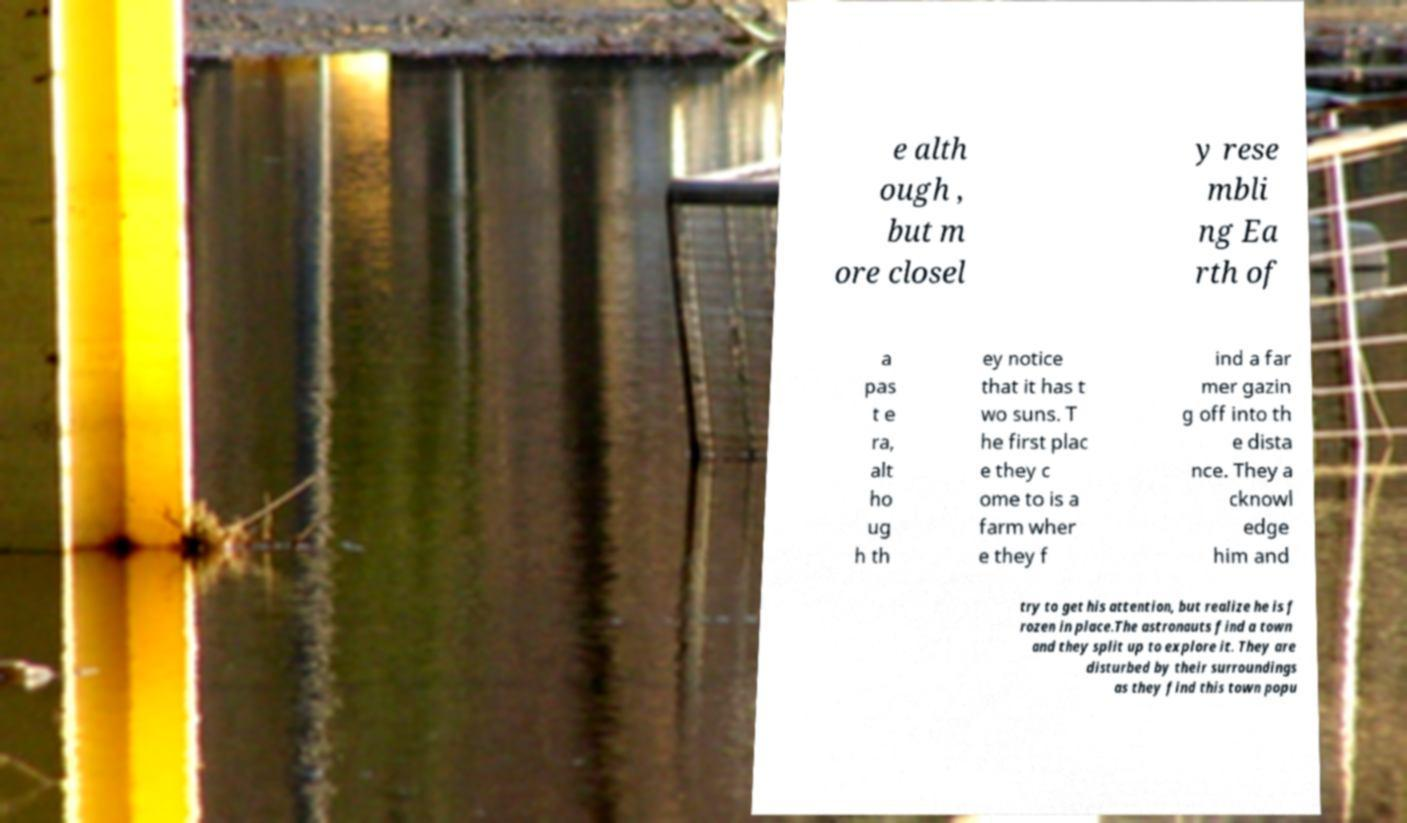Can you accurately transcribe the text from the provided image for me? e alth ough , but m ore closel y rese mbli ng Ea rth of a pas t e ra, alt ho ug h th ey notice that it has t wo suns. T he first plac e they c ome to is a farm wher e they f ind a far mer gazin g off into th e dista nce. They a cknowl edge him and try to get his attention, but realize he is f rozen in place.The astronauts find a town and they split up to explore it. They are disturbed by their surroundings as they find this town popu 